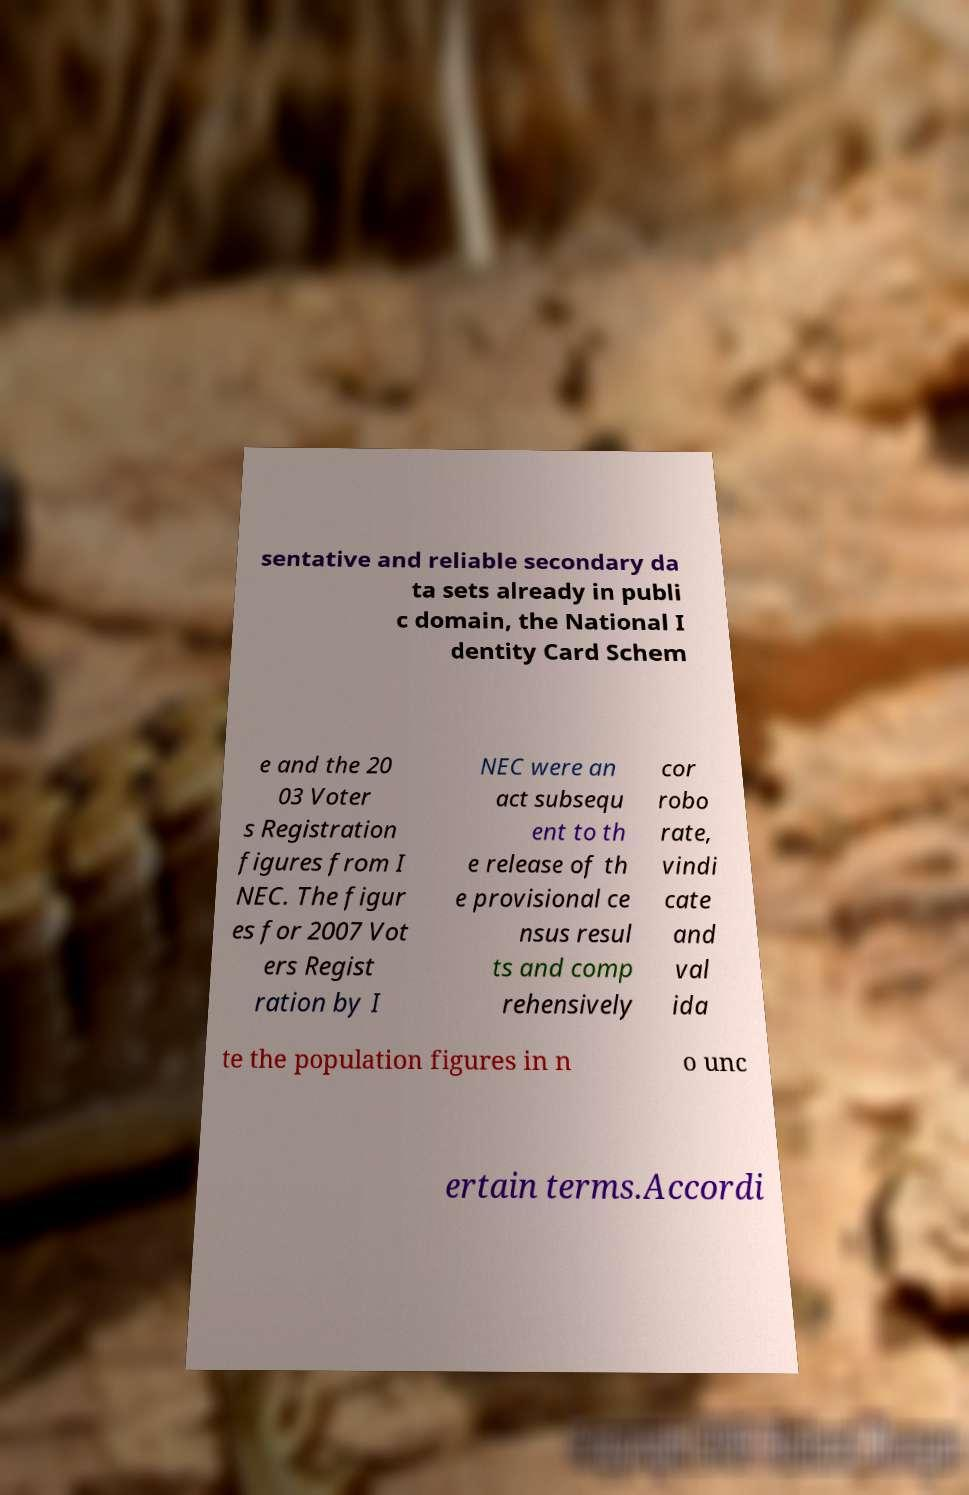Can you read and provide the text displayed in the image?This photo seems to have some interesting text. Can you extract and type it out for me? sentative and reliable secondary da ta sets already in publi c domain, the National I dentity Card Schem e and the 20 03 Voter s Registration figures from I NEC. The figur es for 2007 Vot ers Regist ration by I NEC were an act subsequ ent to th e release of th e provisional ce nsus resul ts and comp rehensively cor robo rate, vindi cate and val ida te the population figures in n o unc ertain terms.Accordi 